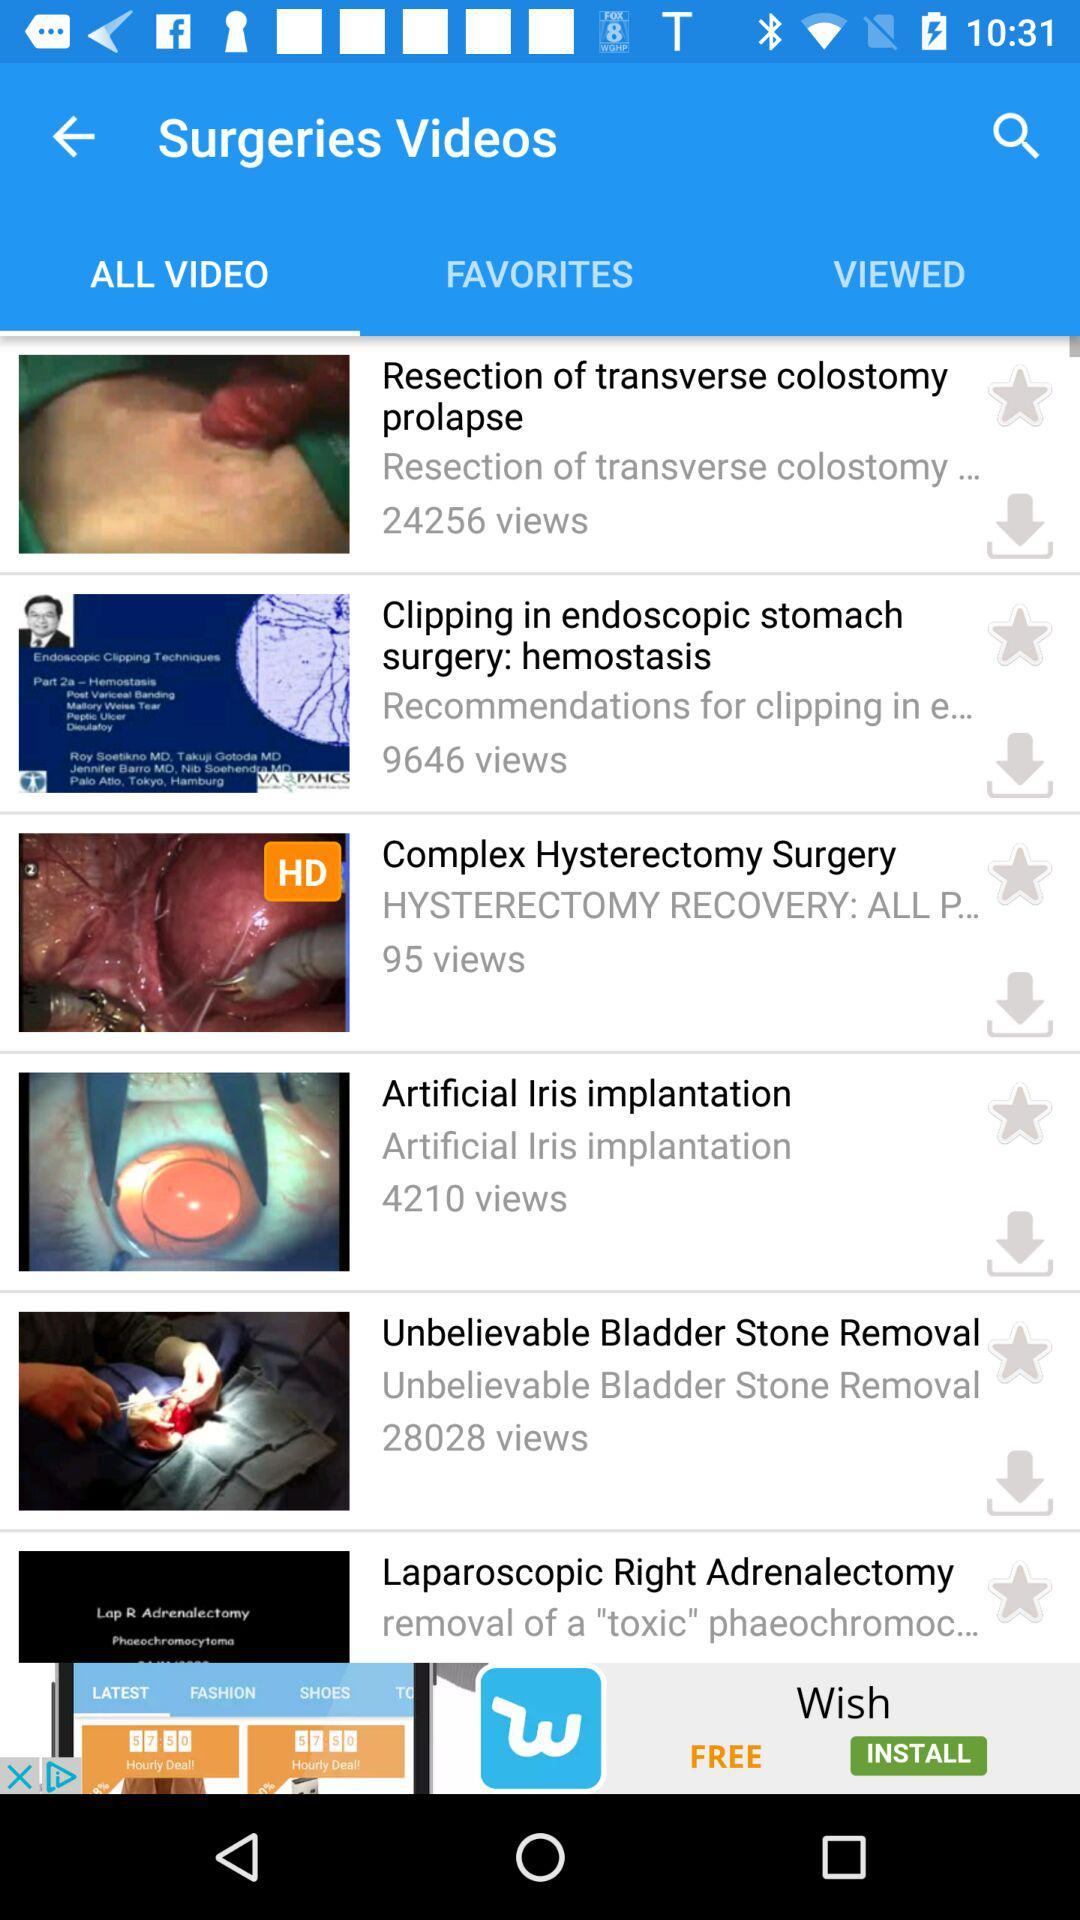Which topic is the video related to? The videos are related to the topic of surgeries. 